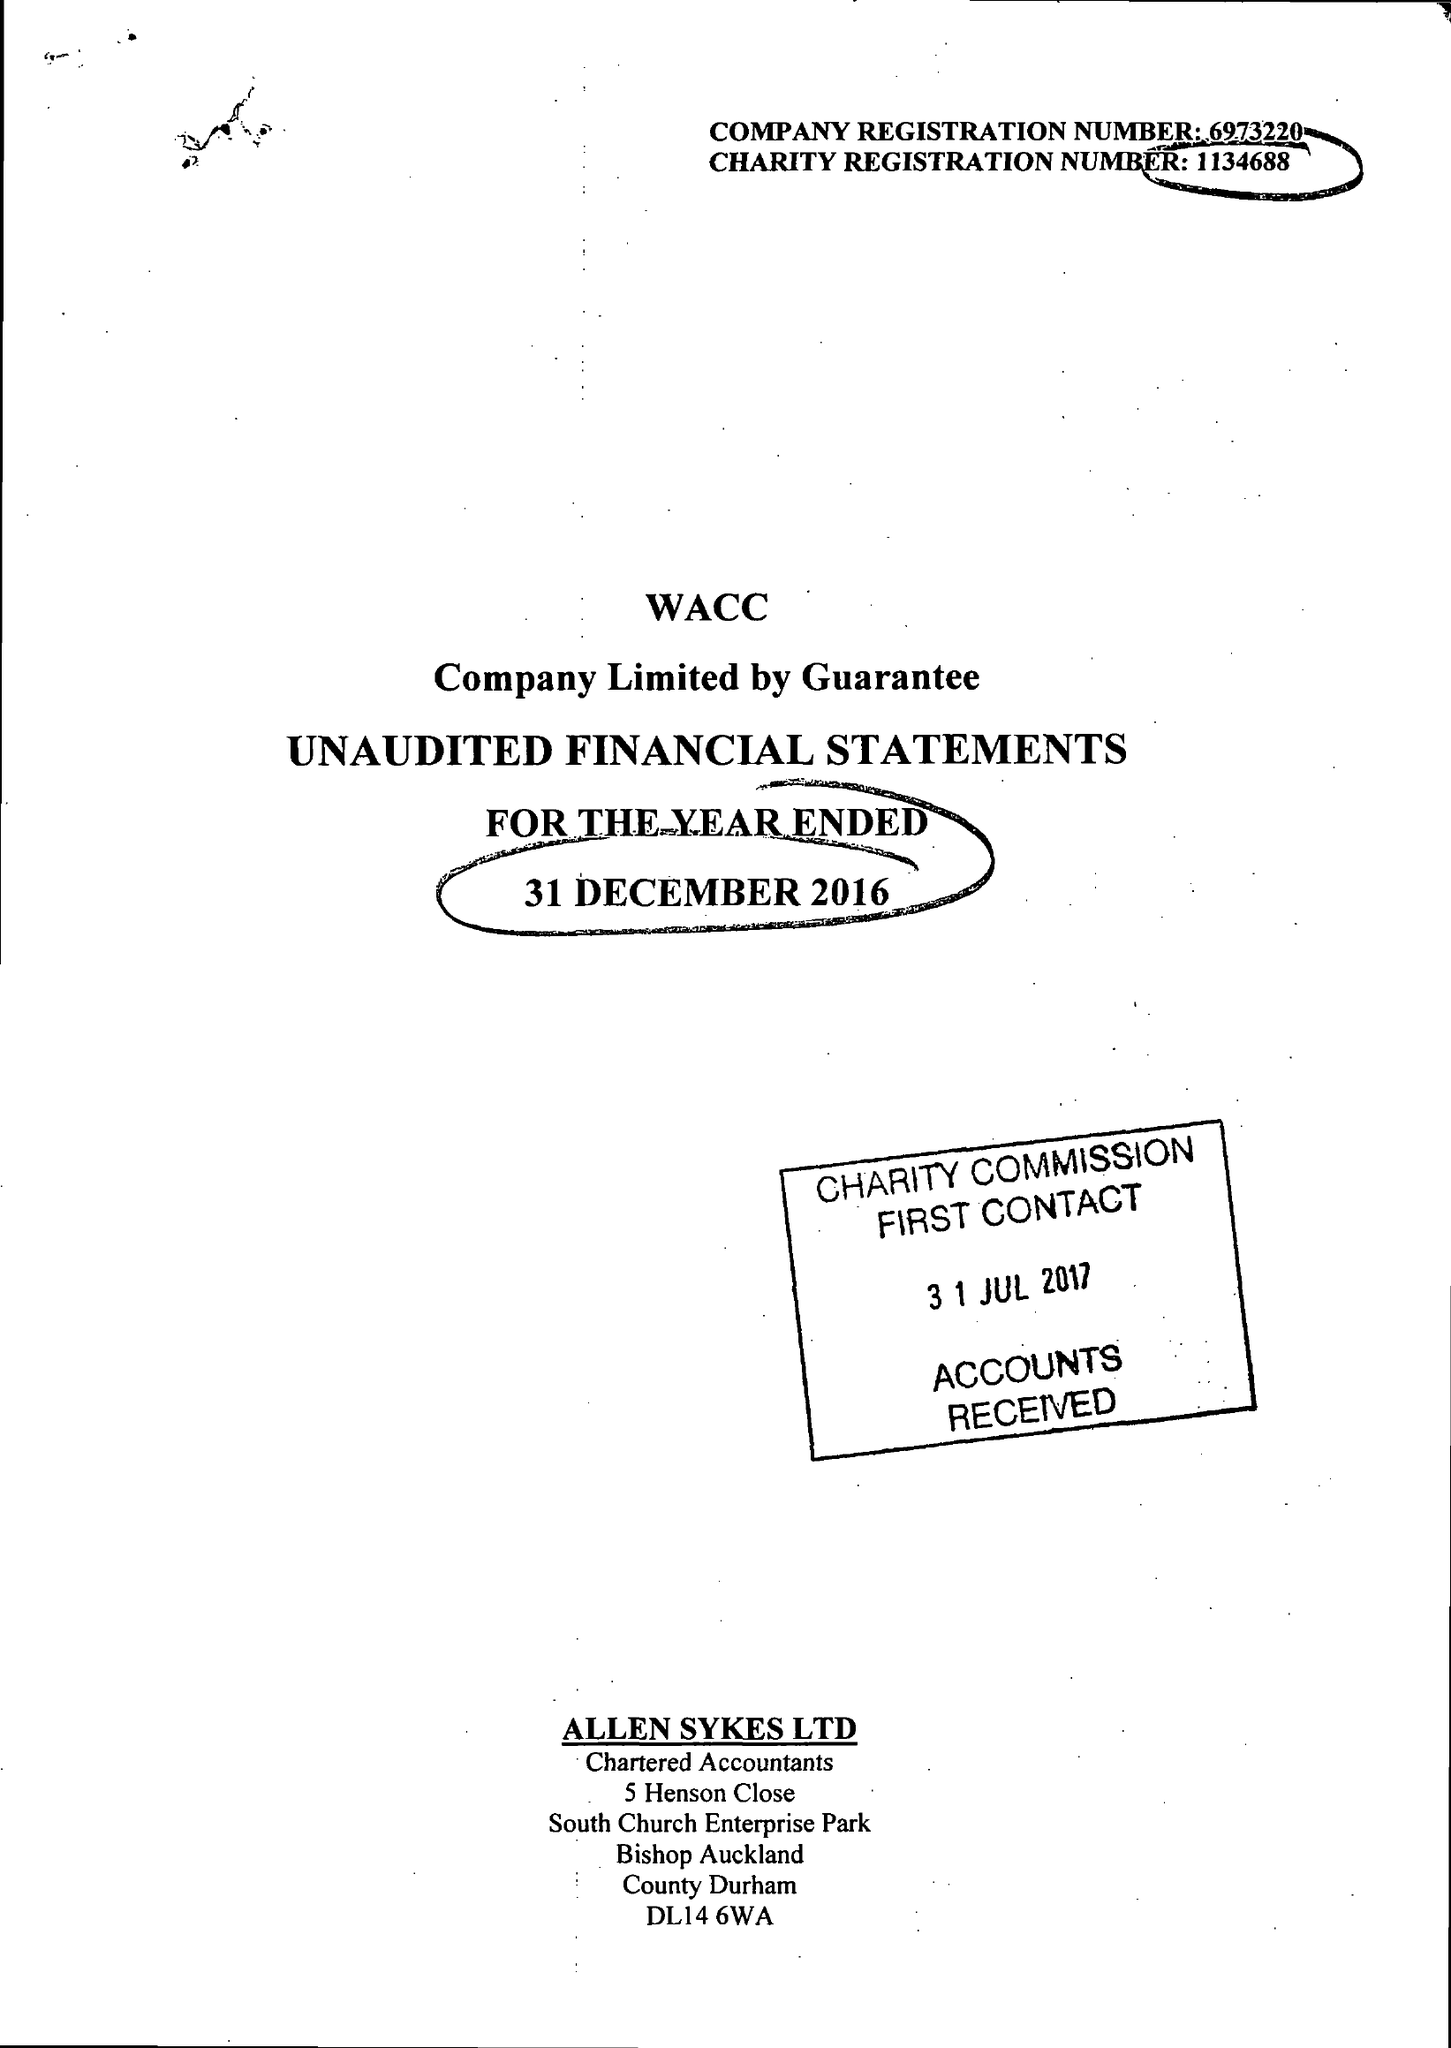What is the value for the address__postcode?
Answer the question using a single word or phrase. DL14 9HJ 